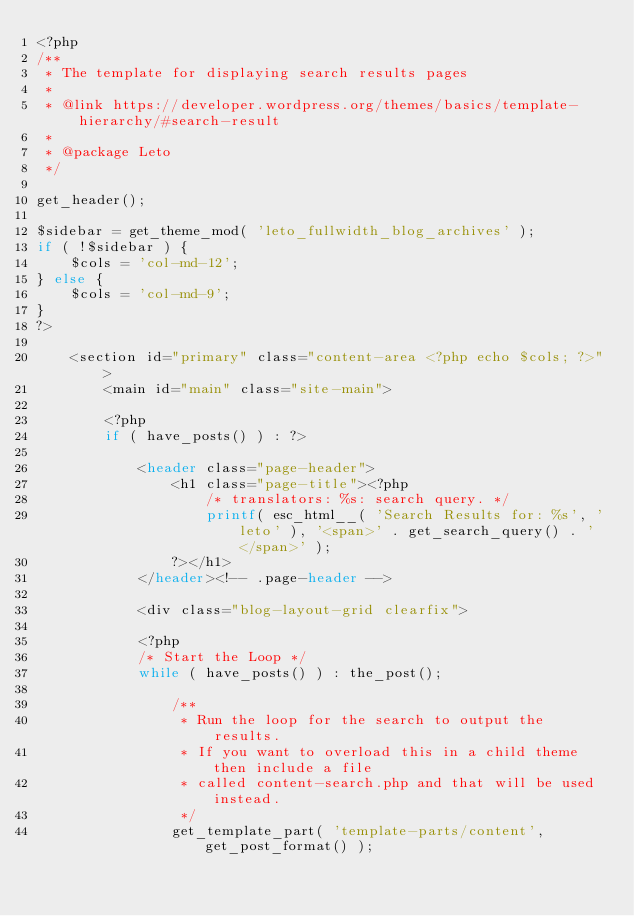<code> <loc_0><loc_0><loc_500><loc_500><_PHP_><?php
/**
 * The template for displaying search results pages
 *
 * @link https://developer.wordpress.org/themes/basics/template-hierarchy/#search-result
 *
 * @package Leto
 */

get_header(); 

$sidebar = get_theme_mod( 'leto_fullwidth_blog_archives' );
if ( !$sidebar ) {
	$cols = 'col-md-12';
} else {
	$cols = 'col-md-9';
}
?>

	<section id="primary" class="content-area <?php echo $cols; ?>">
		<main id="main" class="site-main">

		<?php
		if ( have_posts() ) : ?>

			<header class="page-header">
				<h1 class="page-title"><?php
					/* translators: %s: search query. */
					printf( esc_html__( 'Search Results for: %s', 'leto' ), '<span>' . get_search_query() . '</span>' );
				?></h1>
			</header><!-- .page-header -->

			<div class="blog-layout-grid clearfix">

			<?php
			/* Start the Loop */
			while ( have_posts() ) : the_post();

				/**
				 * Run the loop for the search to output the results.
				 * If you want to overload this in a child theme then include a file
				 * called content-search.php and that will be used instead.
				 */
				get_template_part( 'template-parts/content', get_post_format() );
</code> 